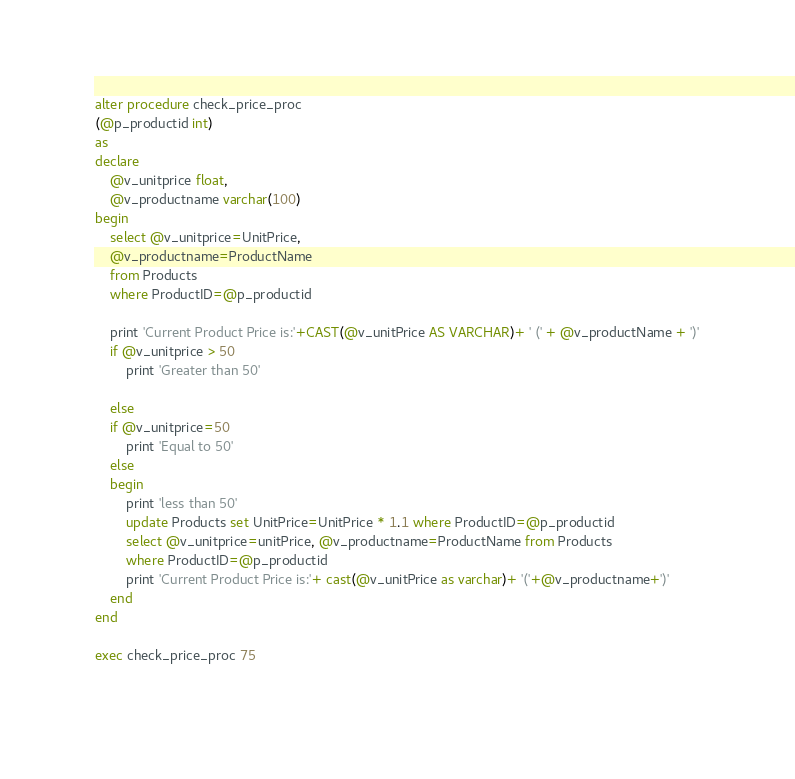<code> <loc_0><loc_0><loc_500><loc_500><_SQL_>alter procedure check_price_proc
(@p_productid int)
as
declare 
	@v_unitprice float,
	@v_productname varchar(100)
begin
	select @v_unitprice=UnitPrice,
	@v_productname=ProductName
	from Products
	where ProductID=@p_productid

	print 'Current Product Price is:'+CAST(@v_unitPrice AS VARCHAR)+ ' (' + @v_productName + ')'
	if @v_unitprice > 50
		print 'Greater than 50'
		
	else 
	if @v_unitprice=50
		print 'Equal to 50'
	else
	begin
		print 'less than 50'
		update Products set UnitPrice=UnitPrice * 1.1 where ProductID=@p_productid
		select @v_unitprice=unitPrice, @v_productname=ProductName from Products
		where ProductID=@p_productid
		print 'Current Product Price is:'+ cast(@v_unitPrice as varchar)+ '('+@v_productname+')'
	end
end

exec check_price_proc 75
	 </code> 